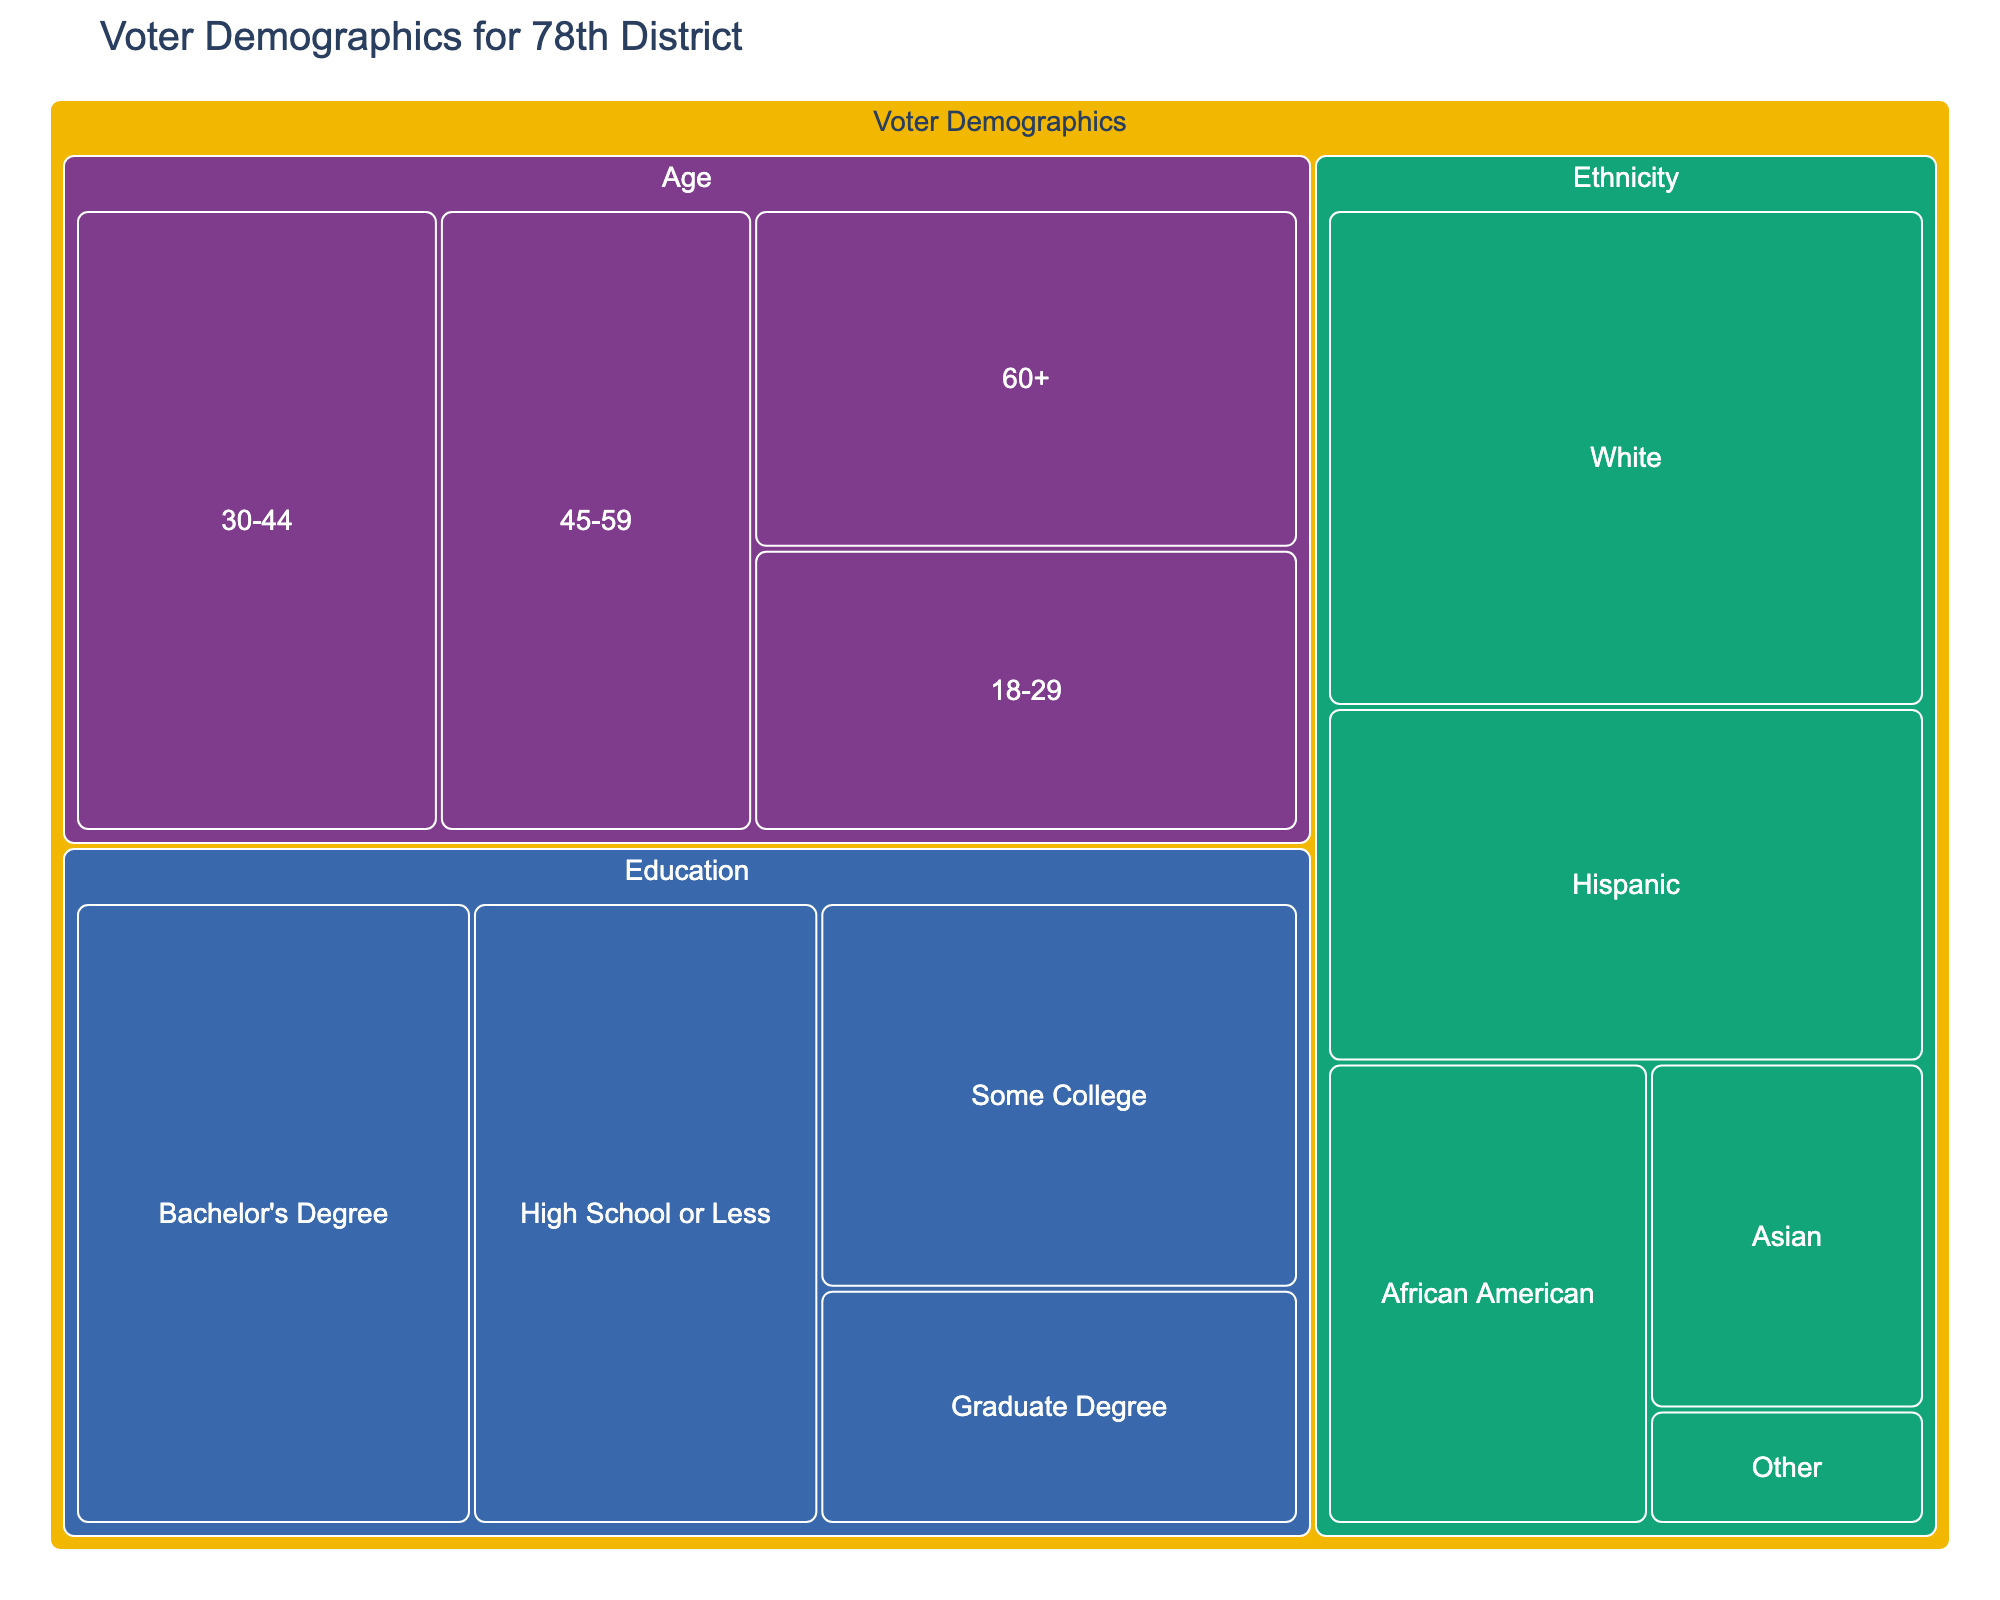What is the title of the treemap? The title is prominently displayed at the top of the figure.
Answer: Voter Demographics for 78th District How many categories are represented in the treemap? By looking at the different colors and heading levels in the figure, you can count the number of distinct main categories such as Age, Ethnicity, and Education.
Answer: 3 What is the largest subcategory by value under the Ethnicity category? Locate the Ethnicity section and identify the subcategory with the largest area/value.
Answer: White Which age group has the smallest number of voters? Check the Age category and observe the subcategories. Find the one with the smallest value.
Answer: 18-29 How many total voters are in the 78th district? Sum the values of all subcategories across all categories.
Answer: 178000 Which education level has fewer voters, Graduate Degree or Some College? Compare the values of the Graduate Degree and Some College subcategories under the Education category.
Answer: Graduate Degree What is the total number of voters in the Education category? Add up the values of all subcategories under the Education category.
Answer: 74000 Between the age group 30-44 and 45-59, which has more voters, and by how much? Subtract the number of voters in the 45-59 age group from the 30-44 age group.
Answer: 3000 more voters (30-44) What percentage of voters identified as Hispanic? Divide the number of Hispanic voters by the total number of voters and multiply by 100.
Answer: 11.24% Which subcategory under Ethnicity has the smallest representation in the treemap? Check the Ethnicity section and find the subcategory with the smallest area/value.
Answer: Other 